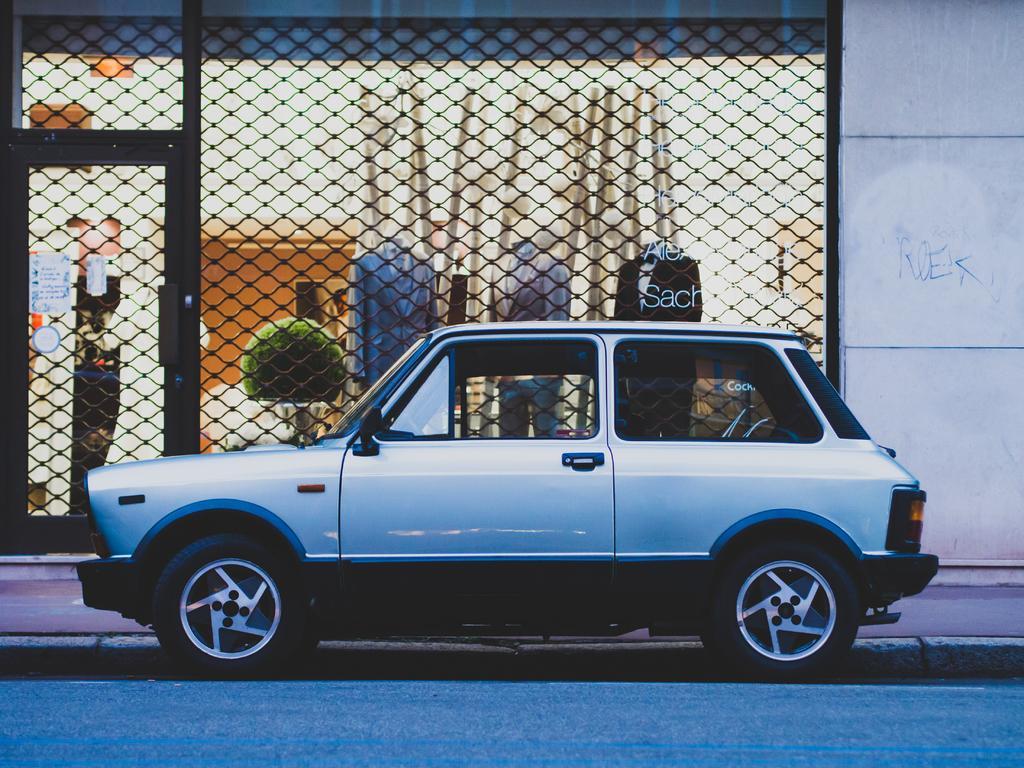In one or two sentences, can you explain what this image depicts? In this picture we can see a car in the front, on the right side there is a wall, in the background we can see mannequins, clothes and a plant, on the left side there is a door, we can see metal mesh in the middle, there is a paper pasted on the left side. 